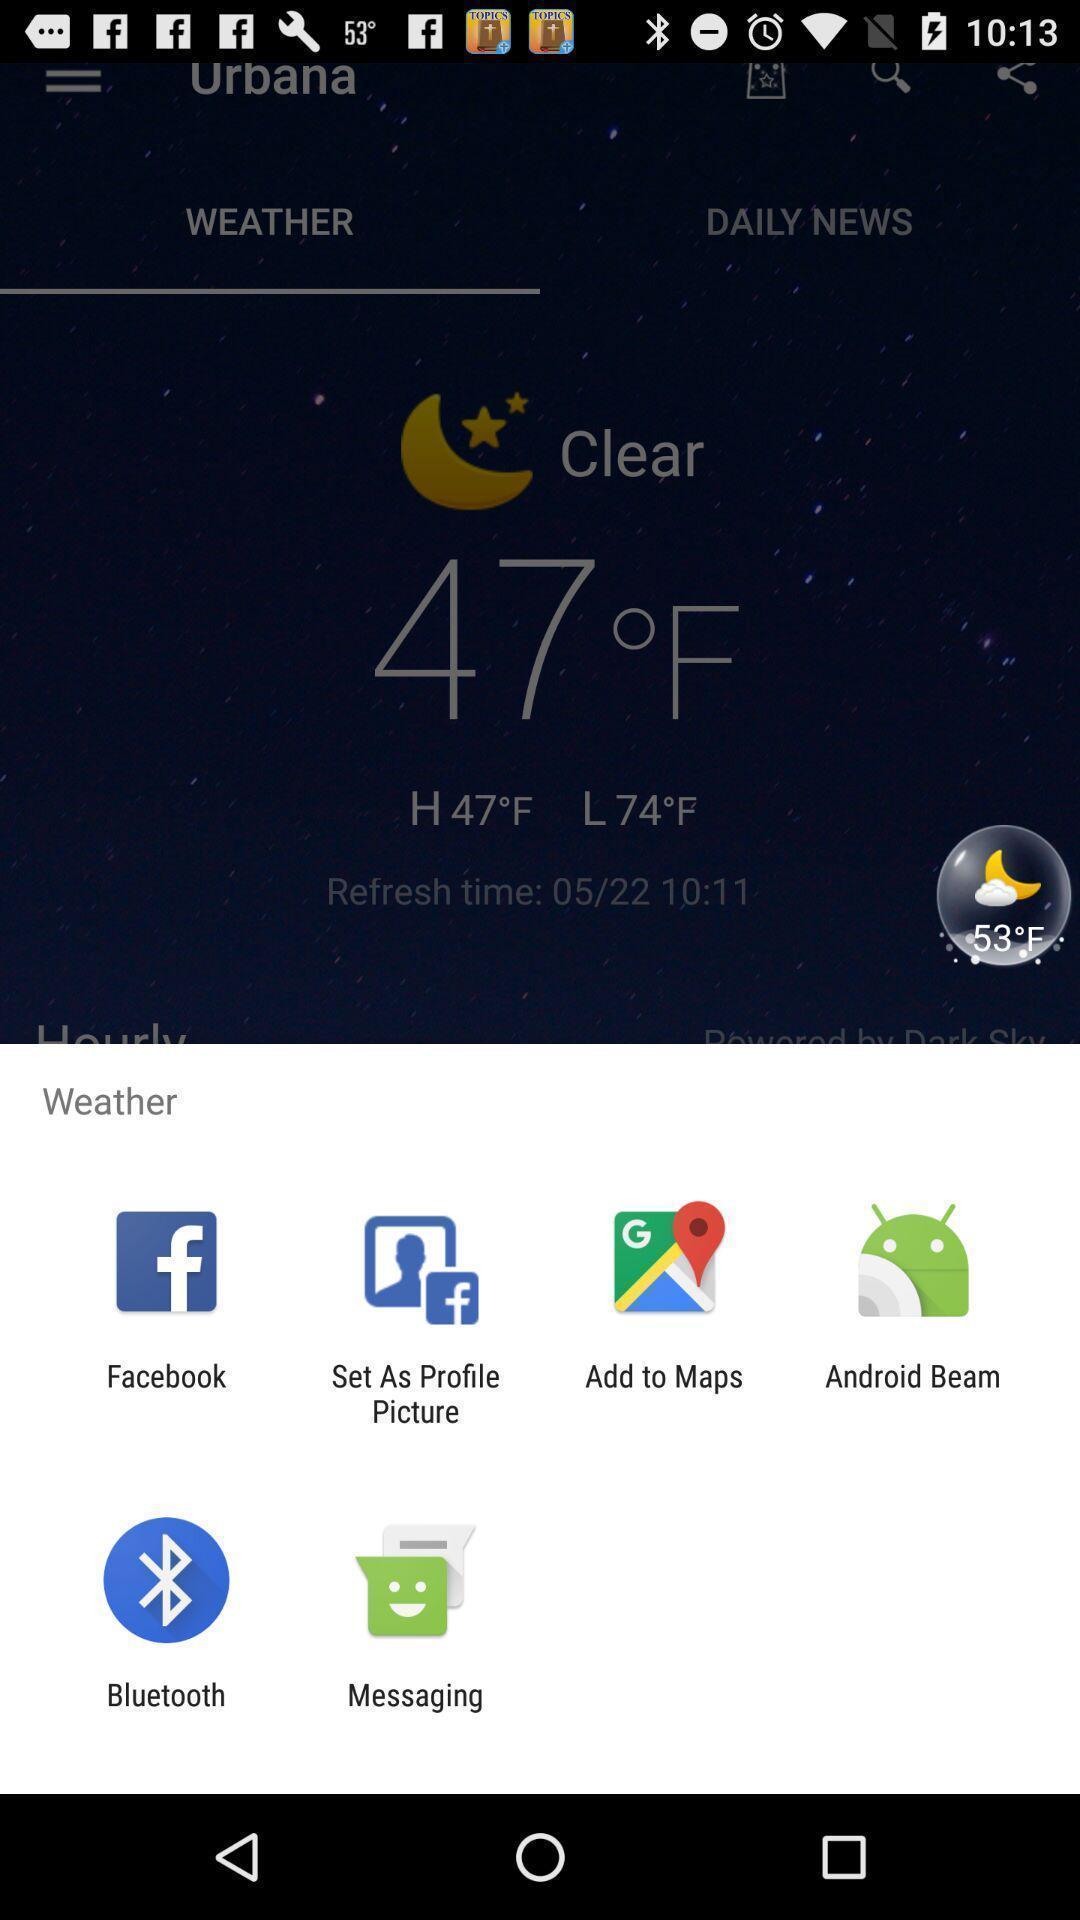What is the overall content of this screenshot? Push up page showing app preference to share. 